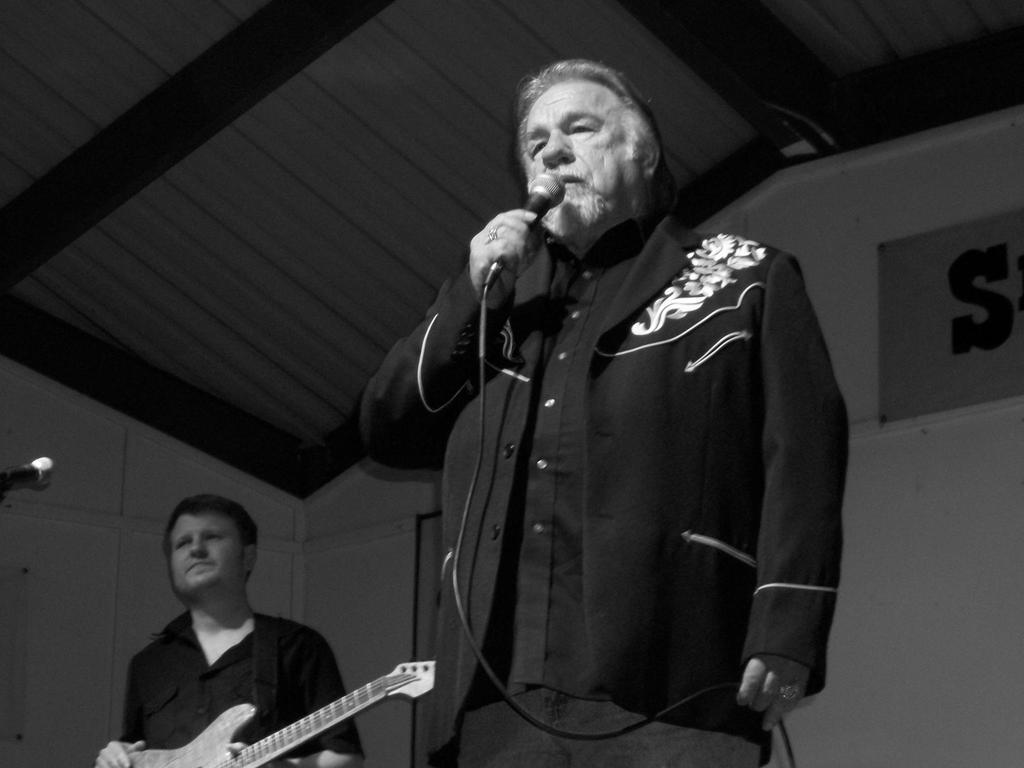In one or two sentences, can you explain what this image depicts? In this image, a old human is holding a mic on his hand. Bottom, we can see another man is holding a guitar. We can see left side, there is a mic. And background, some board, banners. 